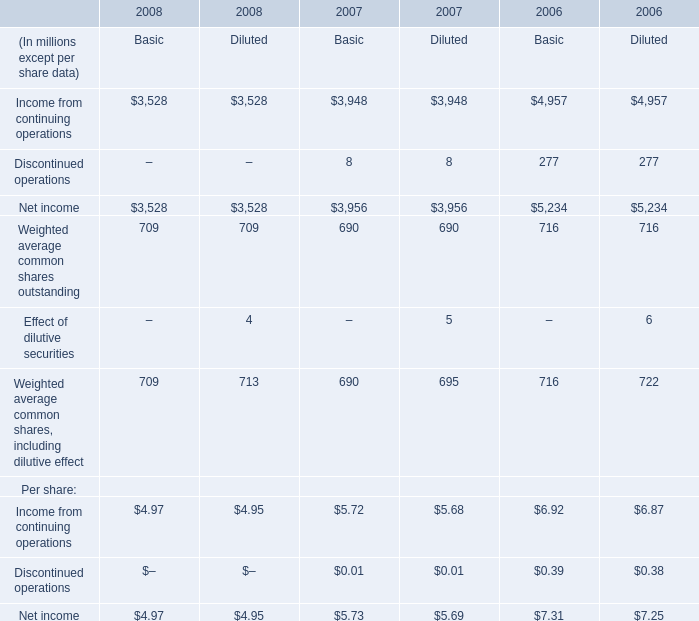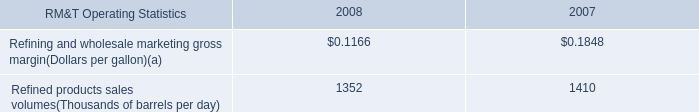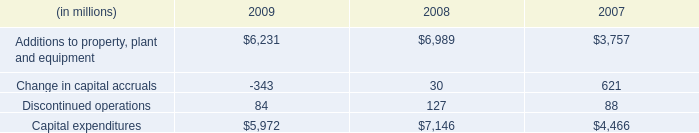What's the sum of Net income of 2006 Basic, and Additions to property, plant and equipment of 2008 ? 
Computations: (5234.0 + 6989.0)
Answer: 12223.0. 